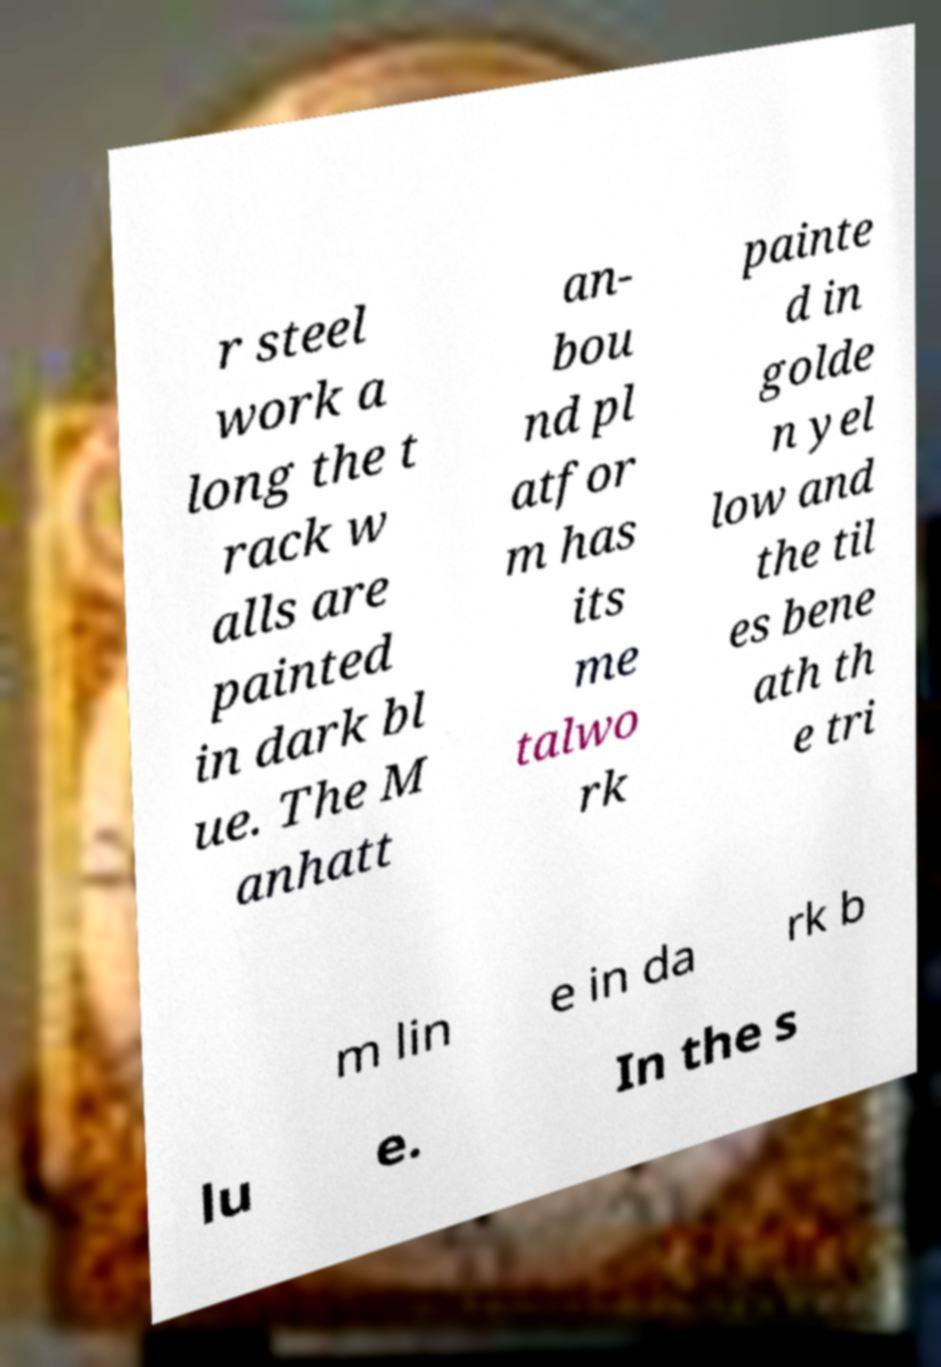What messages or text are displayed in this image? I need them in a readable, typed format. r steel work a long the t rack w alls are painted in dark bl ue. The M anhatt an- bou nd pl atfor m has its me talwo rk painte d in golde n yel low and the til es bene ath th e tri m lin e in da rk b lu e. In the s 